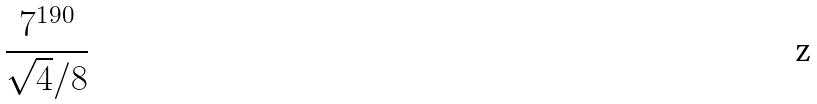Convert formula to latex. <formula><loc_0><loc_0><loc_500><loc_500>\frac { 7 ^ { 1 9 0 } } { \sqrt { 4 } / 8 }</formula> 